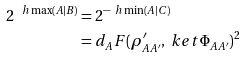Convert formula to latex. <formula><loc_0><loc_0><loc_500><loc_500>2 ^ { \ h \max ( A | B ) } & = 2 ^ { - \ h \min ( A | C ) } \\ & = d _ { A } F ( \rho ^ { \prime } _ { A A ^ { \prime } } , \ k e t { \Phi _ { A A ^ { \prime } } } ) ^ { 2 } \</formula> 